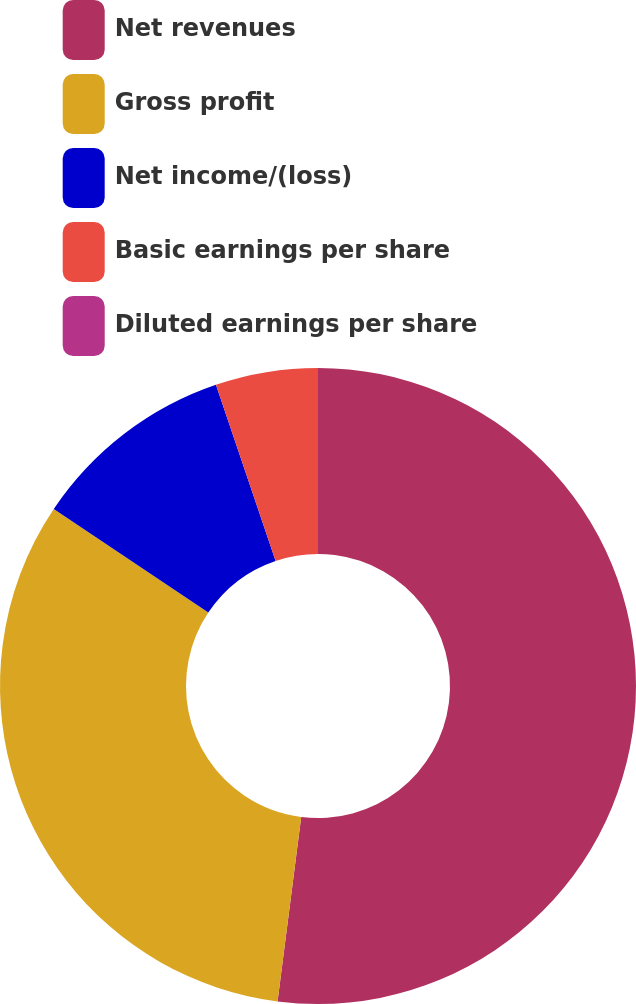Convert chart to OTSL. <chart><loc_0><loc_0><loc_500><loc_500><pie_chart><fcel>Net revenues<fcel>Gross profit<fcel>Net income/(loss)<fcel>Basic earnings per share<fcel>Diluted earnings per share<nl><fcel>52.03%<fcel>32.36%<fcel>10.41%<fcel>5.2%<fcel>0.0%<nl></chart> 